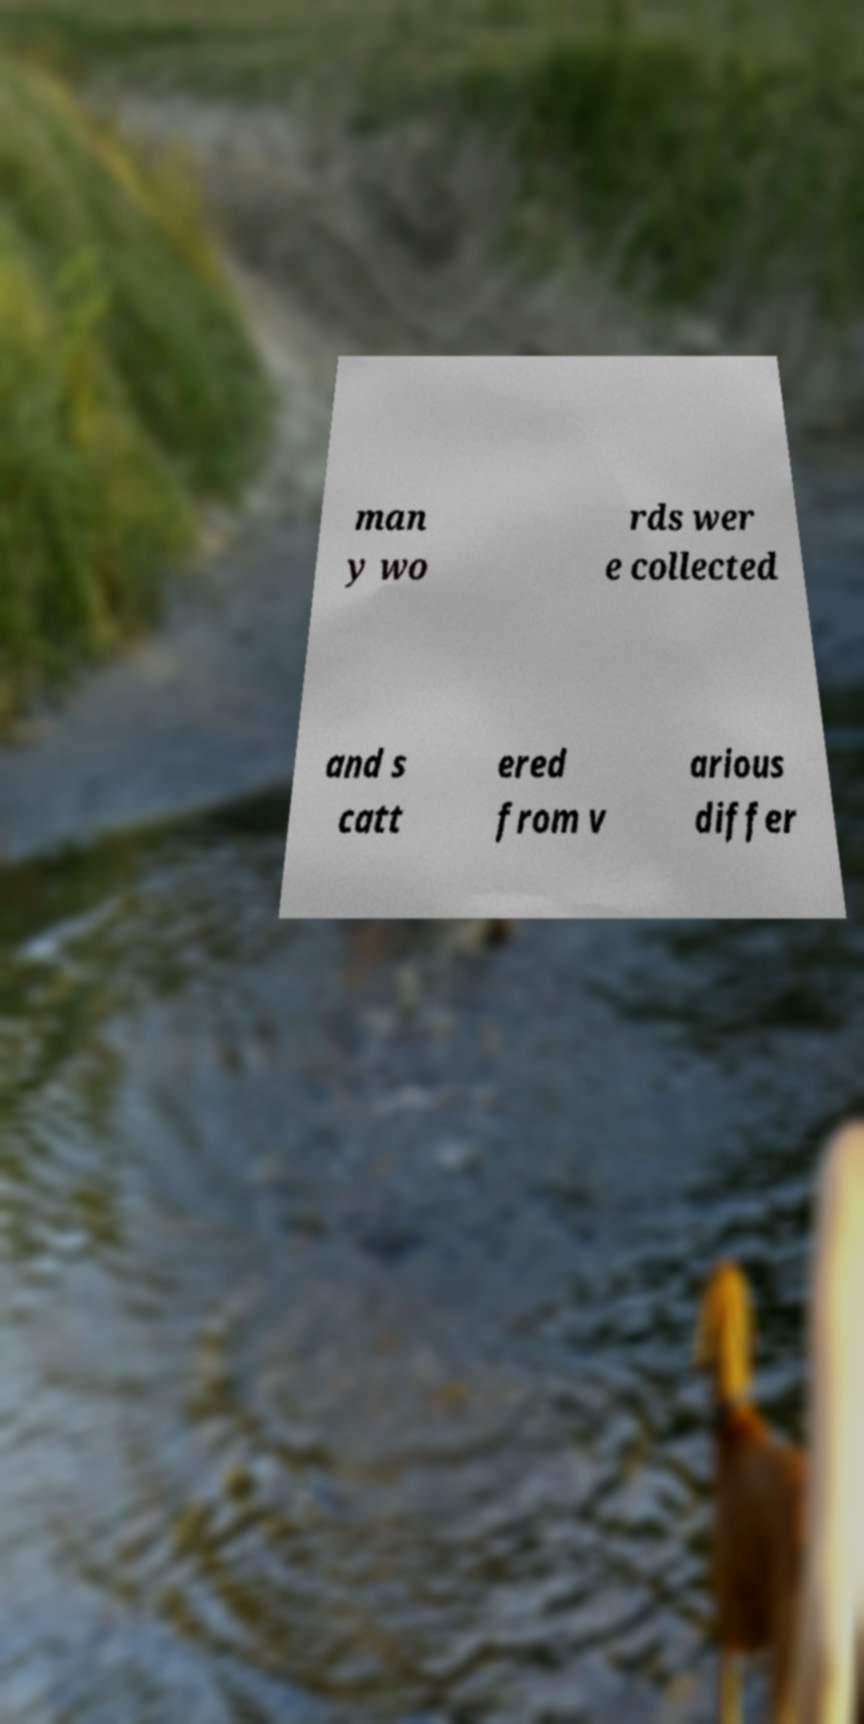What messages or text are displayed in this image? I need them in a readable, typed format. man y wo rds wer e collected and s catt ered from v arious differ 